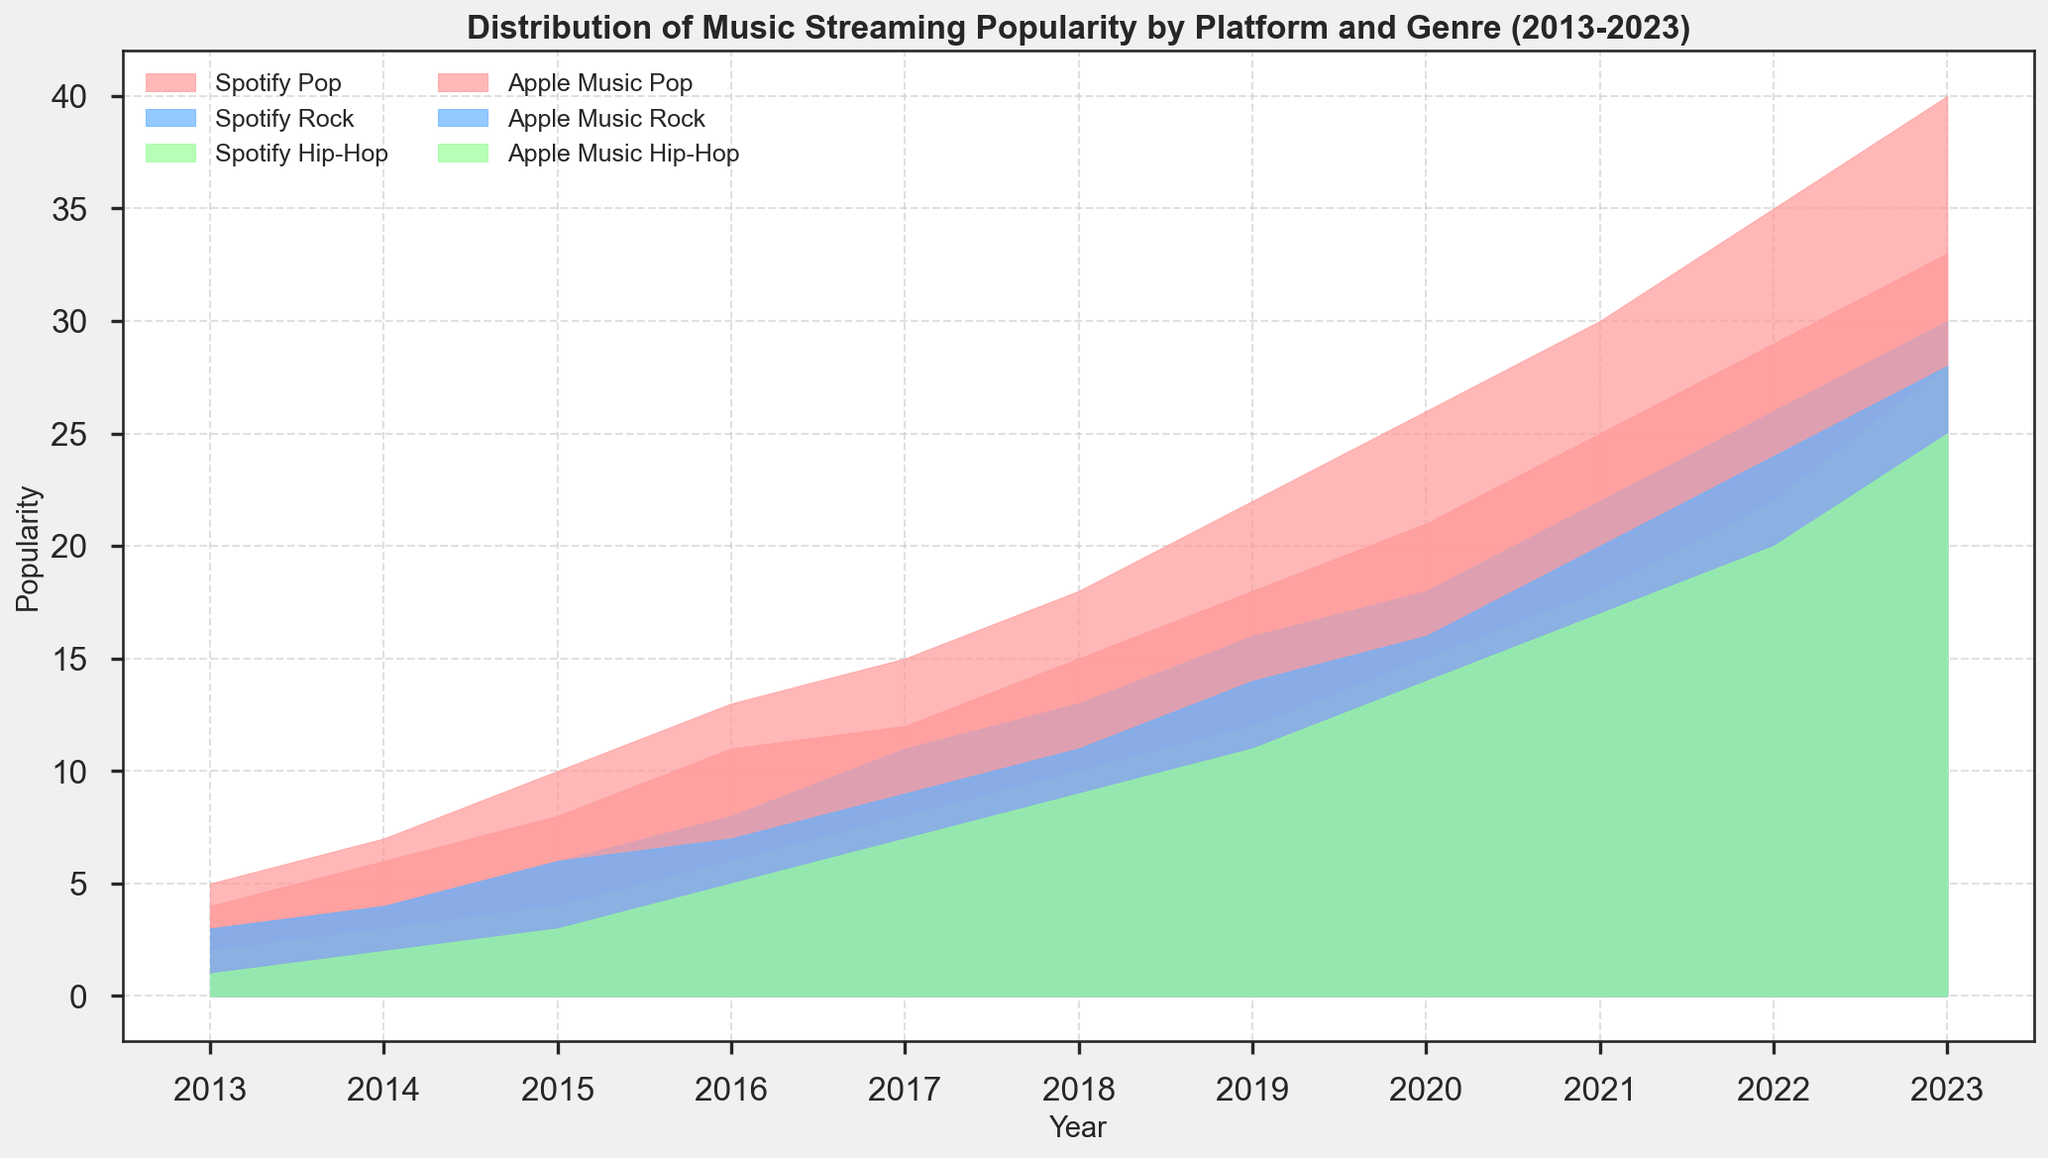What's the overall trend in the popularity of Pop music on Spotify from 2013 to 2023? First, locate the area representing Pop music on Spotify, which is in a specific color. Observe its height changes over the years on the x-axis. The trend shows an increasing height, indicating growth in popularity from 2013 to 2023.
Answer: Increasing Which genre had more popularity on Apple Music in 2020: Rock or Hip-Hop? Find the values corresponding to Rock and Hip-Hop on Apple Music for the year 2020, identified by their respective colors. Compare the heights of these areas. Rock has a higher value compared to Hip-Hop in 2020.
Answer: Rock How does the popularity growth of Hip-Hop on Spotify compare to Apple Music from 2013 to 2023? Notice the width and height of the areas representing Hip-Hop on both Spotify and Apple Music over the years 2013 to 2023. Both platforms show an increase, but Spotify's Hip-Hop popularity grows more rapidly and ends up taller than Apple Music's by 2023.
Answer: Spotify grows more rapidly Which platform had a higher total popularity for all genres combined in 2017? Sum the heights of the areas for all the genres on both Spotify and Apple Music in 2017. Spotify areas collectively appear taller than those of Apple Music.
Answer: Spotify What year did Rock on Spotify surpass the popularity level of Hip-Hop on Apple Music? Examine the years where the height of Rock on Spotify exceeds that of Hip-Hop on Apple Music. This happens in the early years and continues consistently from around 2017 onward.
Answer: 2017 What's the average popularity of Rock on Apple Music over the decade? Sum the popularity values of Rock on Apple Music from 2013 to 2023, then divide by the number of years (11 years). The values are 3, 4, 6, 7, 9, 11, 14, 16, 20, 24, 28. Adding these gives 142. The average is 142/11.
Answer: 12.91 How many genres saw a significant increase in popularity on both platforms from 2013 to 2023? Assess each genre's areas on both Spotify and Apple Music from 2013 to 2023. Pop, Rock, and Hip-Hop all show significant increases on both platforms.
Answer: 3 genres In 2019, how much more popular was Pop on Spotify compared to Hip-Hop on the same platform? Look at the 2019 data for Spotify. Subtract the height of Hip-Hop (12) from the height of Pop (22).
Answer: 10 In which year did Apple Music have more popularity for Pop than Spotify? Identify the years when the height of the Pop area on Apple Music exceeds that of Pop on Spotify. This scenario doesn't occur in the dataset.
Answer: None Which genre showed the smallest difference in popularity between Spotify and Apple Music in 2023? Compare the height differences between Spotify and Apple Music for each genre in 2023. Hip-Hop has a difference of 3, which is the smallest compared to Pop (7) and Rock (2).
Answer: Rock 